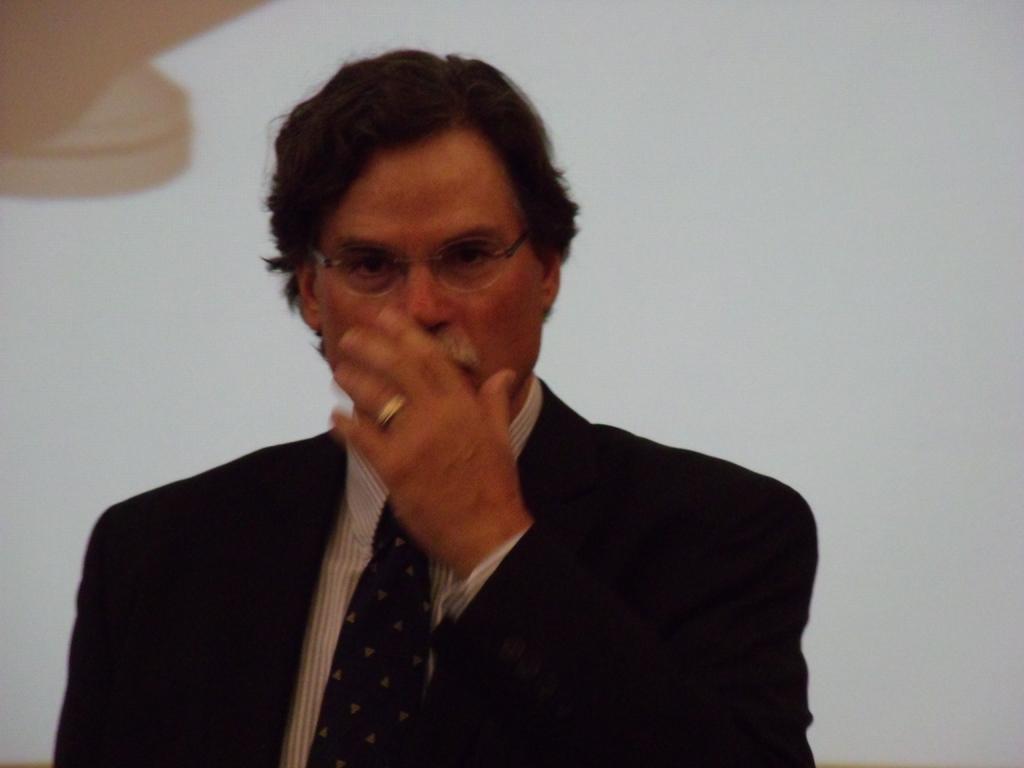Describe this image in one or two sentences. In this picture there is a man who is wearing spectacle, ring and suit. He is standing near to the wall. 